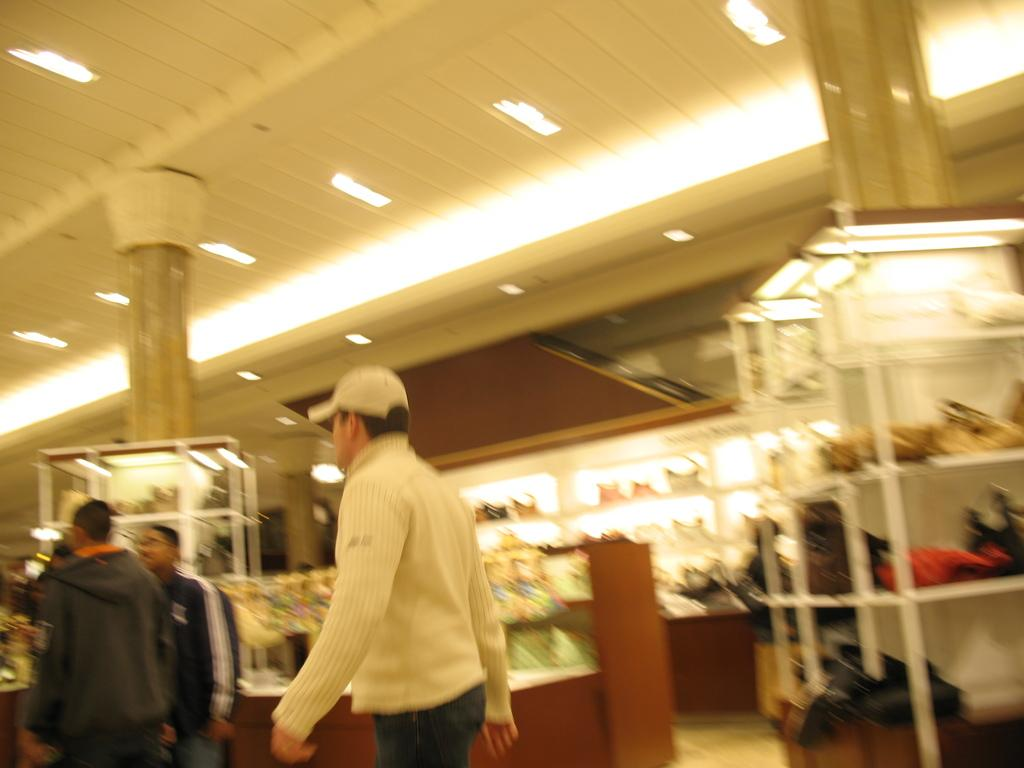What are the persons in the image doing? The persons in the image are walking. On what surface are the persons walking? The persons are walking on the floor. What can be seen in the background of the image? Shops, lights, and a roof are visible in the background of the image. What is the name of the scientific theory that the ice is demonstrating in the image? There is no ice present in the image, so it cannot be used to demonstrate any scientific theory. 